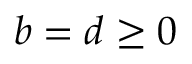<formula> <loc_0><loc_0><loc_500><loc_500>b = d \geq 0</formula> 